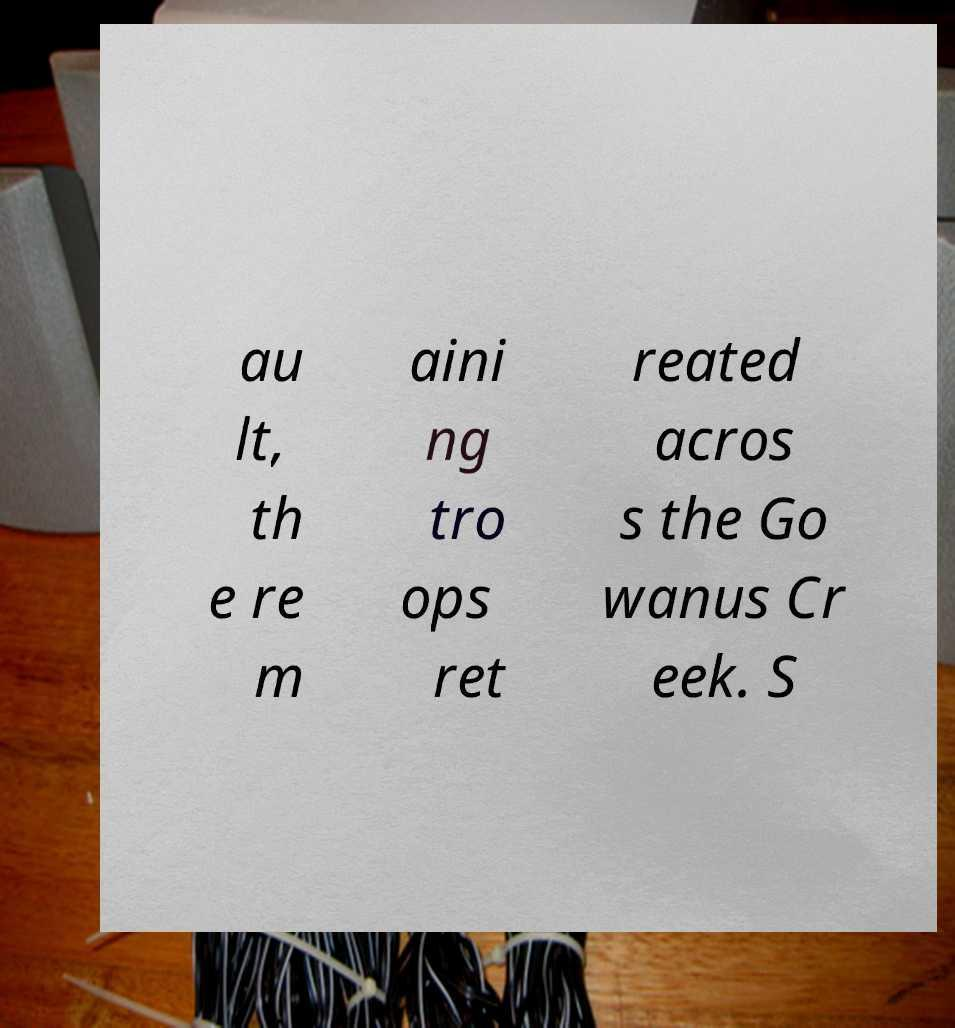Can you read and provide the text displayed in the image?This photo seems to have some interesting text. Can you extract and type it out for me? au lt, th e re m aini ng tro ops ret reated acros s the Go wanus Cr eek. S 